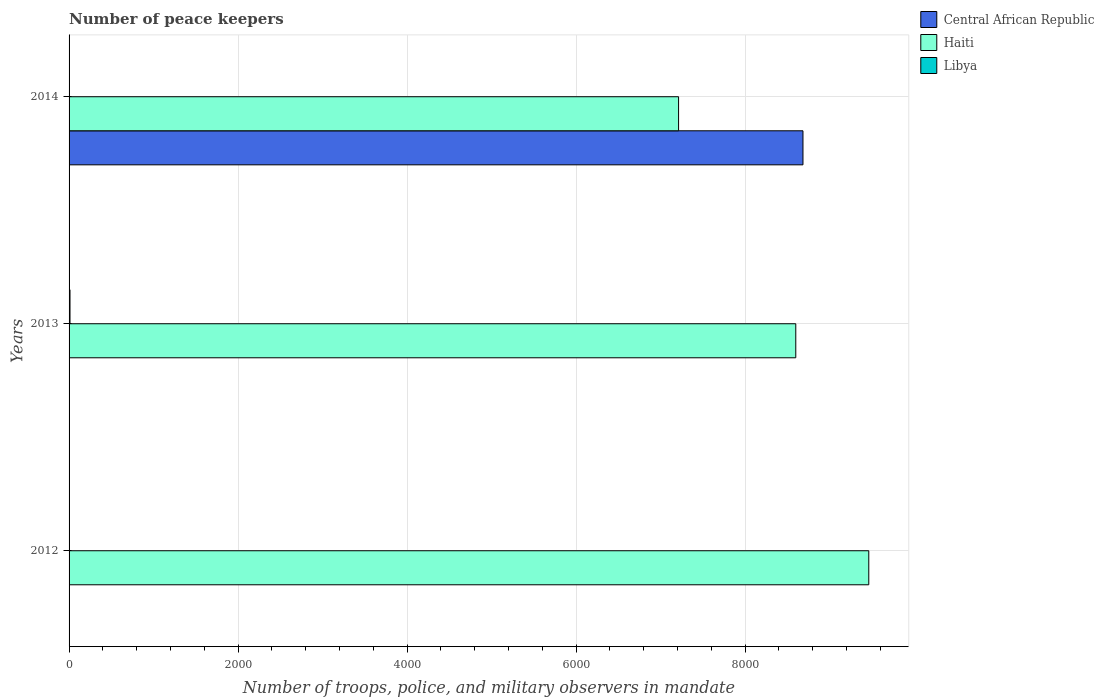How many different coloured bars are there?
Provide a succinct answer. 3. Are the number of bars per tick equal to the number of legend labels?
Your answer should be compact. Yes. How many bars are there on the 3rd tick from the top?
Your answer should be compact. 3. How many bars are there on the 3rd tick from the bottom?
Ensure brevity in your answer.  3. In how many cases, is the number of bars for a given year not equal to the number of legend labels?
Make the answer very short. 0. What is the number of peace keepers in in Libya in 2014?
Your answer should be compact. 2. Across all years, what is the maximum number of peace keepers in in Libya?
Give a very brief answer. 11. In which year was the number of peace keepers in in Libya maximum?
Your answer should be very brief. 2013. What is the total number of peace keepers in in Haiti in the graph?
Your answer should be very brief. 2.53e+04. What is the difference between the number of peace keepers in in Libya in 2014 and the number of peace keepers in in Central African Republic in 2012?
Your response must be concise. -2. What is the average number of peace keepers in in Haiti per year?
Your response must be concise. 8425.67. In the year 2012, what is the difference between the number of peace keepers in in Central African Republic and number of peace keepers in in Libya?
Offer a terse response. 2. What is the ratio of the number of peace keepers in in Libya in 2012 to that in 2013?
Offer a terse response. 0.18. What is the difference between the highest and the second highest number of peace keepers in in Haiti?
Provide a short and direct response. 864. What is the difference between the highest and the lowest number of peace keepers in in Central African Republic?
Ensure brevity in your answer.  8681. In how many years, is the number of peace keepers in in Haiti greater than the average number of peace keepers in in Haiti taken over all years?
Provide a short and direct response. 2. Is the sum of the number of peace keepers in in Central African Republic in 2012 and 2013 greater than the maximum number of peace keepers in in Libya across all years?
Offer a terse response. No. What does the 3rd bar from the top in 2013 represents?
Offer a very short reply. Central African Republic. What does the 3rd bar from the bottom in 2012 represents?
Ensure brevity in your answer.  Libya. Is it the case that in every year, the sum of the number of peace keepers in in Central African Republic and number of peace keepers in in Haiti is greater than the number of peace keepers in in Libya?
Keep it short and to the point. Yes. How many bars are there?
Your answer should be very brief. 9. Are all the bars in the graph horizontal?
Provide a succinct answer. Yes. What is the difference between two consecutive major ticks on the X-axis?
Keep it short and to the point. 2000. Are the values on the major ticks of X-axis written in scientific E-notation?
Provide a succinct answer. No. Does the graph contain any zero values?
Make the answer very short. No. Does the graph contain grids?
Your answer should be compact. Yes. What is the title of the graph?
Your answer should be compact. Number of peace keepers. Does "Finland" appear as one of the legend labels in the graph?
Ensure brevity in your answer.  No. What is the label or title of the X-axis?
Offer a very short reply. Number of troops, police, and military observers in mandate. What is the label or title of the Y-axis?
Ensure brevity in your answer.  Years. What is the Number of troops, police, and military observers in mandate of Haiti in 2012?
Your response must be concise. 9464. What is the Number of troops, police, and military observers in mandate of Libya in 2012?
Offer a terse response. 2. What is the Number of troops, police, and military observers in mandate in Central African Republic in 2013?
Your answer should be very brief. 4. What is the Number of troops, police, and military observers in mandate of Haiti in 2013?
Ensure brevity in your answer.  8600. What is the Number of troops, police, and military observers in mandate in Central African Republic in 2014?
Ensure brevity in your answer.  8685. What is the Number of troops, police, and military observers in mandate in Haiti in 2014?
Offer a terse response. 7213. Across all years, what is the maximum Number of troops, police, and military observers in mandate of Central African Republic?
Your answer should be compact. 8685. Across all years, what is the maximum Number of troops, police, and military observers in mandate of Haiti?
Provide a short and direct response. 9464. Across all years, what is the maximum Number of troops, police, and military observers in mandate of Libya?
Provide a short and direct response. 11. Across all years, what is the minimum Number of troops, police, and military observers in mandate in Central African Republic?
Your answer should be compact. 4. Across all years, what is the minimum Number of troops, police, and military observers in mandate of Haiti?
Offer a very short reply. 7213. Across all years, what is the minimum Number of troops, police, and military observers in mandate in Libya?
Provide a succinct answer. 2. What is the total Number of troops, police, and military observers in mandate in Central African Republic in the graph?
Your answer should be compact. 8693. What is the total Number of troops, police, and military observers in mandate of Haiti in the graph?
Offer a terse response. 2.53e+04. What is the total Number of troops, police, and military observers in mandate of Libya in the graph?
Provide a short and direct response. 15. What is the difference between the Number of troops, police, and military observers in mandate in Haiti in 2012 and that in 2013?
Offer a terse response. 864. What is the difference between the Number of troops, police, and military observers in mandate in Libya in 2012 and that in 2013?
Provide a succinct answer. -9. What is the difference between the Number of troops, police, and military observers in mandate in Central African Republic in 2012 and that in 2014?
Your response must be concise. -8681. What is the difference between the Number of troops, police, and military observers in mandate in Haiti in 2012 and that in 2014?
Your response must be concise. 2251. What is the difference between the Number of troops, police, and military observers in mandate in Central African Republic in 2013 and that in 2014?
Give a very brief answer. -8681. What is the difference between the Number of troops, police, and military observers in mandate in Haiti in 2013 and that in 2014?
Keep it short and to the point. 1387. What is the difference between the Number of troops, police, and military observers in mandate in Central African Republic in 2012 and the Number of troops, police, and military observers in mandate in Haiti in 2013?
Keep it short and to the point. -8596. What is the difference between the Number of troops, police, and military observers in mandate of Central African Republic in 2012 and the Number of troops, police, and military observers in mandate of Libya in 2013?
Ensure brevity in your answer.  -7. What is the difference between the Number of troops, police, and military observers in mandate of Haiti in 2012 and the Number of troops, police, and military observers in mandate of Libya in 2013?
Your response must be concise. 9453. What is the difference between the Number of troops, police, and military observers in mandate in Central African Republic in 2012 and the Number of troops, police, and military observers in mandate in Haiti in 2014?
Ensure brevity in your answer.  -7209. What is the difference between the Number of troops, police, and military observers in mandate in Haiti in 2012 and the Number of troops, police, and military observers in mandate in Libya in 2014?
Your response must be concise. 9462. What is the difference between the Number of troops, police, and military observers in mandate of Central African Republic in 2013 and the Number of troops, police, and military observers in mandate of Haiti in 2014?
Offer a terse response. -7209. What is the difference between the Number of troops, police, and military observers in mandate of Central African Republic in 2013 and the Number of troops, police, and military observers in mandate of Libya in 2014?
Give a very brief answer. 2. What is the difference between the Number of troops, police, and military observers in mandate in Haiti in 2013 and the Number of troops, police, and military observers in mandate in Libya in 2014?
Offer a terse response. 8598. What is the average Number of troops, police, and military observers in mandate in Central African Republic per year?
Provide a short and direct response. 2897.67. What is the average Number of troops, police, and military observers in mandate of Haiti per year?
Your response must be concise. 8425.67. What is the average Number of troops, police, and military observers in mandate in Libya per year?
Give a very brief answer. 5. In the year 2012, what is the difference between the Number of troops, police, and military observers in mandate in Central African Republic and Number of troops, police, and military observers in mandate in Haiti?
Your answer should be compact. -9460. In the year 2012, what is the difference between the Number of troops, police, and military observers in mandate in Central African Republic and Number of troops, police, and military observers in mandate in Libya?
Offer a terse response. 2. In the year 2012, what is the difference between the Number of troops, police, and military observers in mandate of Haiti and Number of troops, police, and military observers in mandate of Libya?
Provide a short and direct response. 9462. In the year 2013, what is the difference between the Number of troops, police, and military observers in mandate in Central African Republic and Number of troops, police, and military observers in mandate in Haiti?
Offer a very short reply. -8596. In the year 2013, what is the difference between the Number of troops, police, and military observers in mandate in Haiti and Number of troops, police, and military observers in mandate in Libya?
Offer a terse response. 8589. In the year 2014, what is the difference between the Number of troops, police, and military observers in mandate in Central African Republic and Number of troops, police, and military observers in mandate in Haiti?
Make the answer very short. 1472. In the year 2014, what is the difference between the Number of troops, police, and military observers in mandate in Central African Republic and Number of troops, police, and military observers in mandate in Libya?
Your answer should be very brief. 8683. In the year 2014, what is the difference between the Number of troops, police, and military observers in mandate in Haiti and Number of troops, police, and military observers in mandate in Libya?
Your answer should be compact. 7211. What is the ratio of the Number of troops, police, and military observers in mandate in Haiti in 2012 to that in 2013?
Make the answer very short. 1.1. What is the ratio of the Number of troops, police, and military observers in mandate of Libya in 2012 to that in 2013?
Make the answer very short. 0.18. What is the ratio of the Number of troops, police, and military observers in mandate of Central African Republic in 2012 to that in 2014?
Your answer should be very brief. 0. What is the ratio of the Number of troops, police, and military observers in mandate in Haiti in 2012 to that in 2014?
Make the answer very short. 1.31. What is the ratio of the Number of troops, police, and military observers in mandate of Haiti in 2013 to that in 2014?
Give a very brief answer. 1.19. What is the ratio of the Number of troops, police, and military observers in mandate in Libya in 2013 to that in 2014?
Offer a terse response. 5.5. What is the difference between the highest and the second highest Number of troops, police, and military observers in mandate in Central African Republic?
Offer a very short reply. 8681. What is the difference between the highest and the second highest Number of troops, police, and military observers in mandate in Haiti?
Provide a succinct answer. 864. What is the difference between the highest and the second highest Number of troops, police, and military observers in mandate of Libya?
Ensure brevity in your answer.  9. What is the difference between the highest and the lowest Number of troops, police, and military observers in mandate of Central African Republic?
Your answer should be very brief. 8681. What is the difference between the highest and the lowest Number of troops, police, and military observers in mandate of Haiti?
Offer a terse response. 2251. What is the difference between the highest and the lowest Number of troops, police, and military observers in mandate of Libya?
Offer a very short reply. 9. 